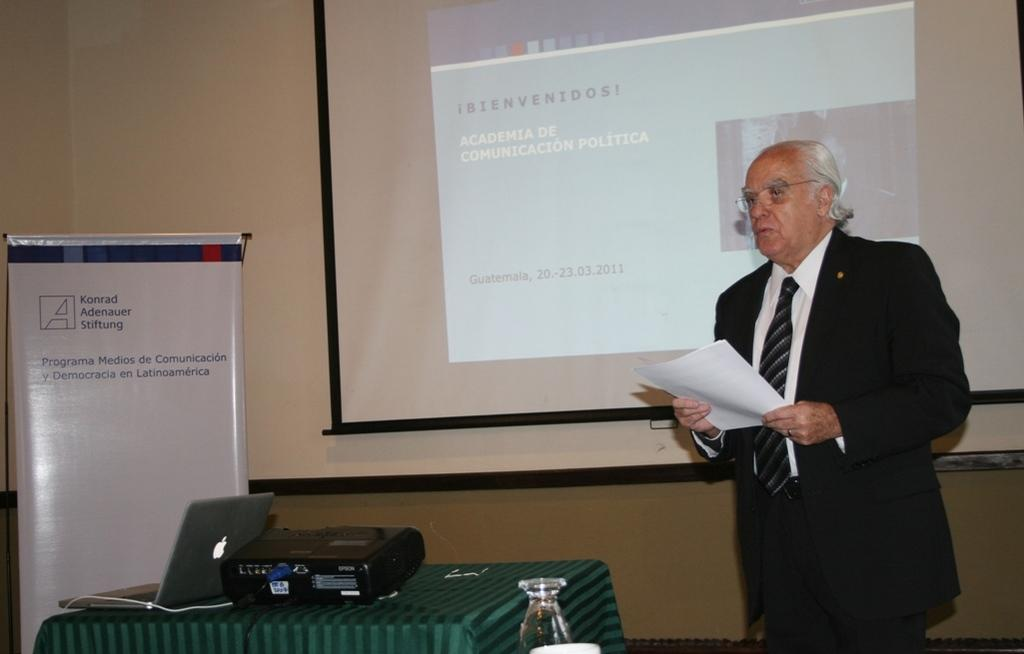What is the man in the image doing? The man is standing and holding papers. What electronic device can be seen in the image? There is a projector and a laptop in the image. What object is present on the table in the image? There is a cable on the table in the image. What is the man likely using the laptop for? The man might be using the laptop to display information on the screen using the projector. What is visible on the wall in the background of the image? There is a banner and a screen on the wall in the background of the image. What type of ant is crawling on the man's shoulder in the image? There are no ants present in the image. How many soldiers are visible in the image? There are no soldiers or army members present in the image. 